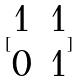<formula> <loc_0><loc_0><loc_500><loc_500>[ \begin{matrix} 1 & 1 \\ 0 & 1 \end{matrix} ]</formula> 